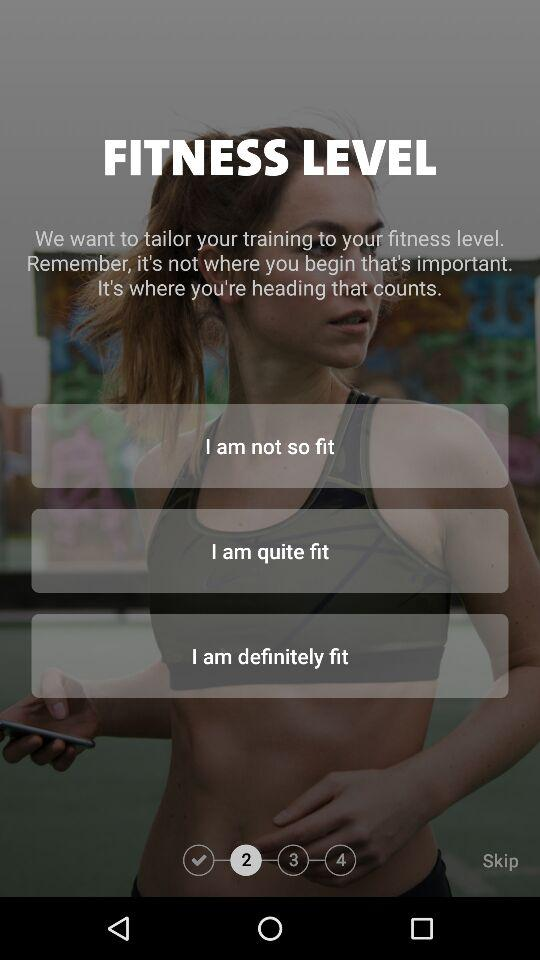Which fitness level has been completed?
When the provided information is insufficient, respond with <no answer>. <no answer> 